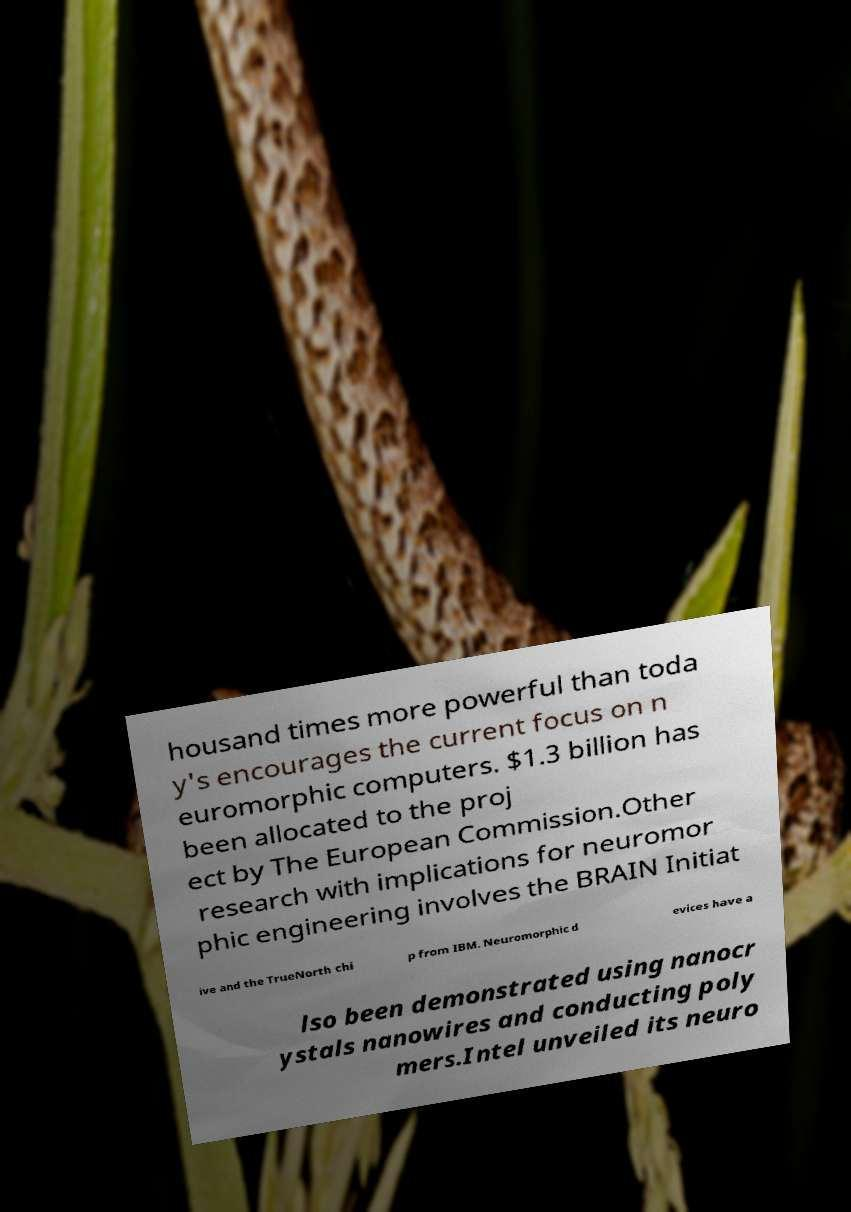Please read and relay the text visible in this image. What does it say? housand times more powerful than toda y's encourages the current focus on n euromorphic computers. $1.3 billion has been allocated to the proj ect by The European Commission.Other research with implications for neuromor phic engineering involves the BRAIN Initiat ive and the TrueNorth chi p from IBM. Neuromorphic d evices have a lso been demonstrated using nanocr ystals nanowires and conducting poly mers.Intel unveiled its neuro 